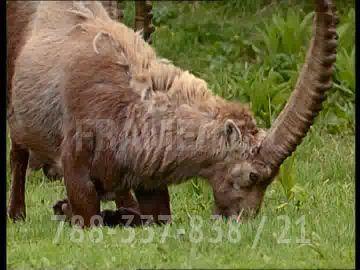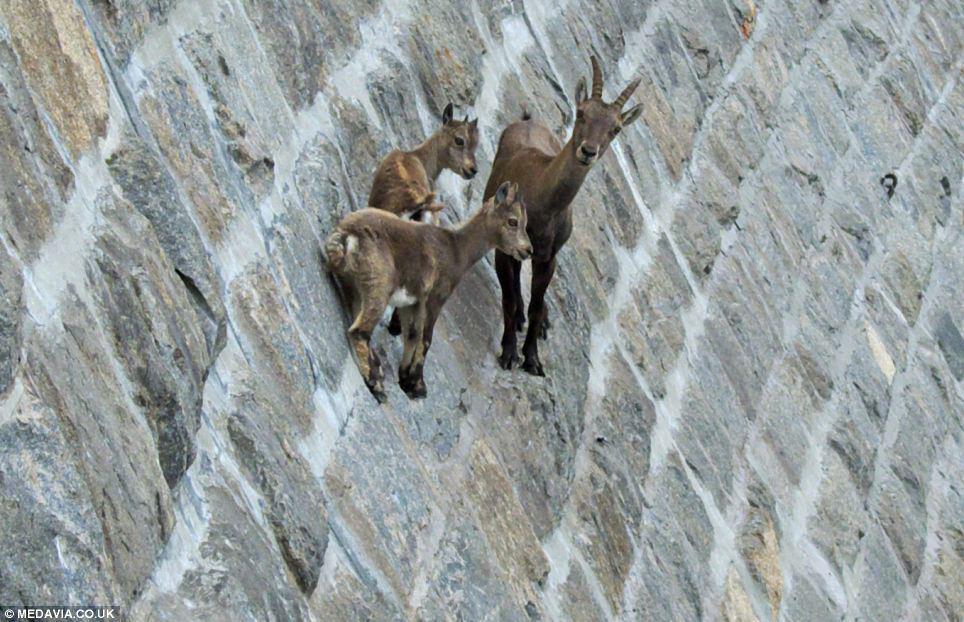The first image is the image on the left, the second image is the image on the right. Analyze the images presented: Is the assertion "An image contains only a rightward-facing horned animal in a pose on green grass." valid? Answer yes or no. Yes. 